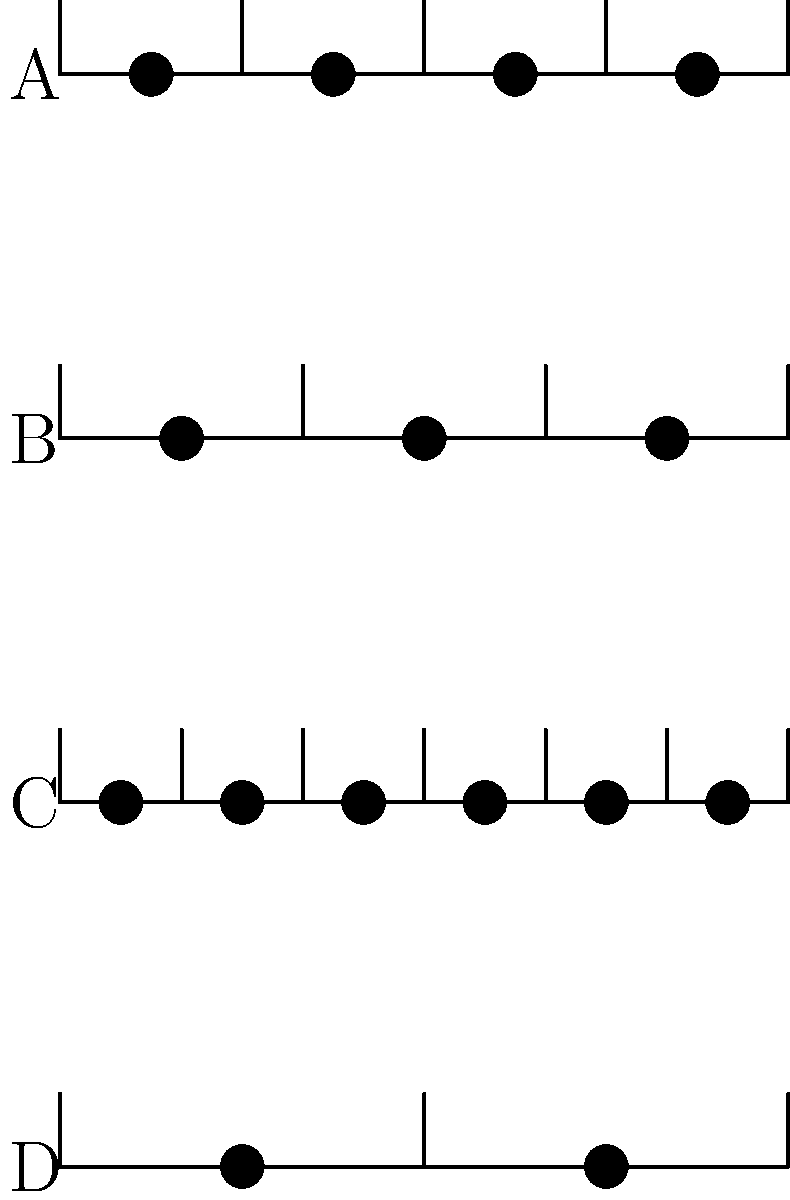Examine the rhythmic pattern diagrams labeled A, B, C, and D. Each diagram represents one measure of music with vertical lines indicating beat divisions and dots representing notes. Which of these patterns most likely represents a time signature commonly found in a Viennese waltz? Let's analyze each pattern step-by-step:

1. Pattern A: This shows 4 equally spaced notes in a measure divided into 4 beats. This represents a 4/4 time signature, common in many genres including country music.

2. Pattern B: This shows 3 equally spaced notes in a measure divided into 3 beats. This represents a 3/4 time signature, which is the characteristic time signature of a waltz, including the Viennese waltz.

3. Pattern C: This shows 6 equally spaced notes in a measure divided into 6 beats. This represents a 6/8 time signature, often used in compound duple meter pieces.

4. Pattern D: This shows 2 equally spaced notes in a measure divided into 2 beats. This represents a 2/4 time signature, common in marches and polkas.

The Viennese waltz, a classical dance form, is characterized by its 3/4 time signature. This gives it the distinctive "ONE-two-three, ONE-two-three" rhythm that dancers move to. Among the given patterns, only Pattern B shows this 3-beat structure typical of a waltz.
Answer: B 